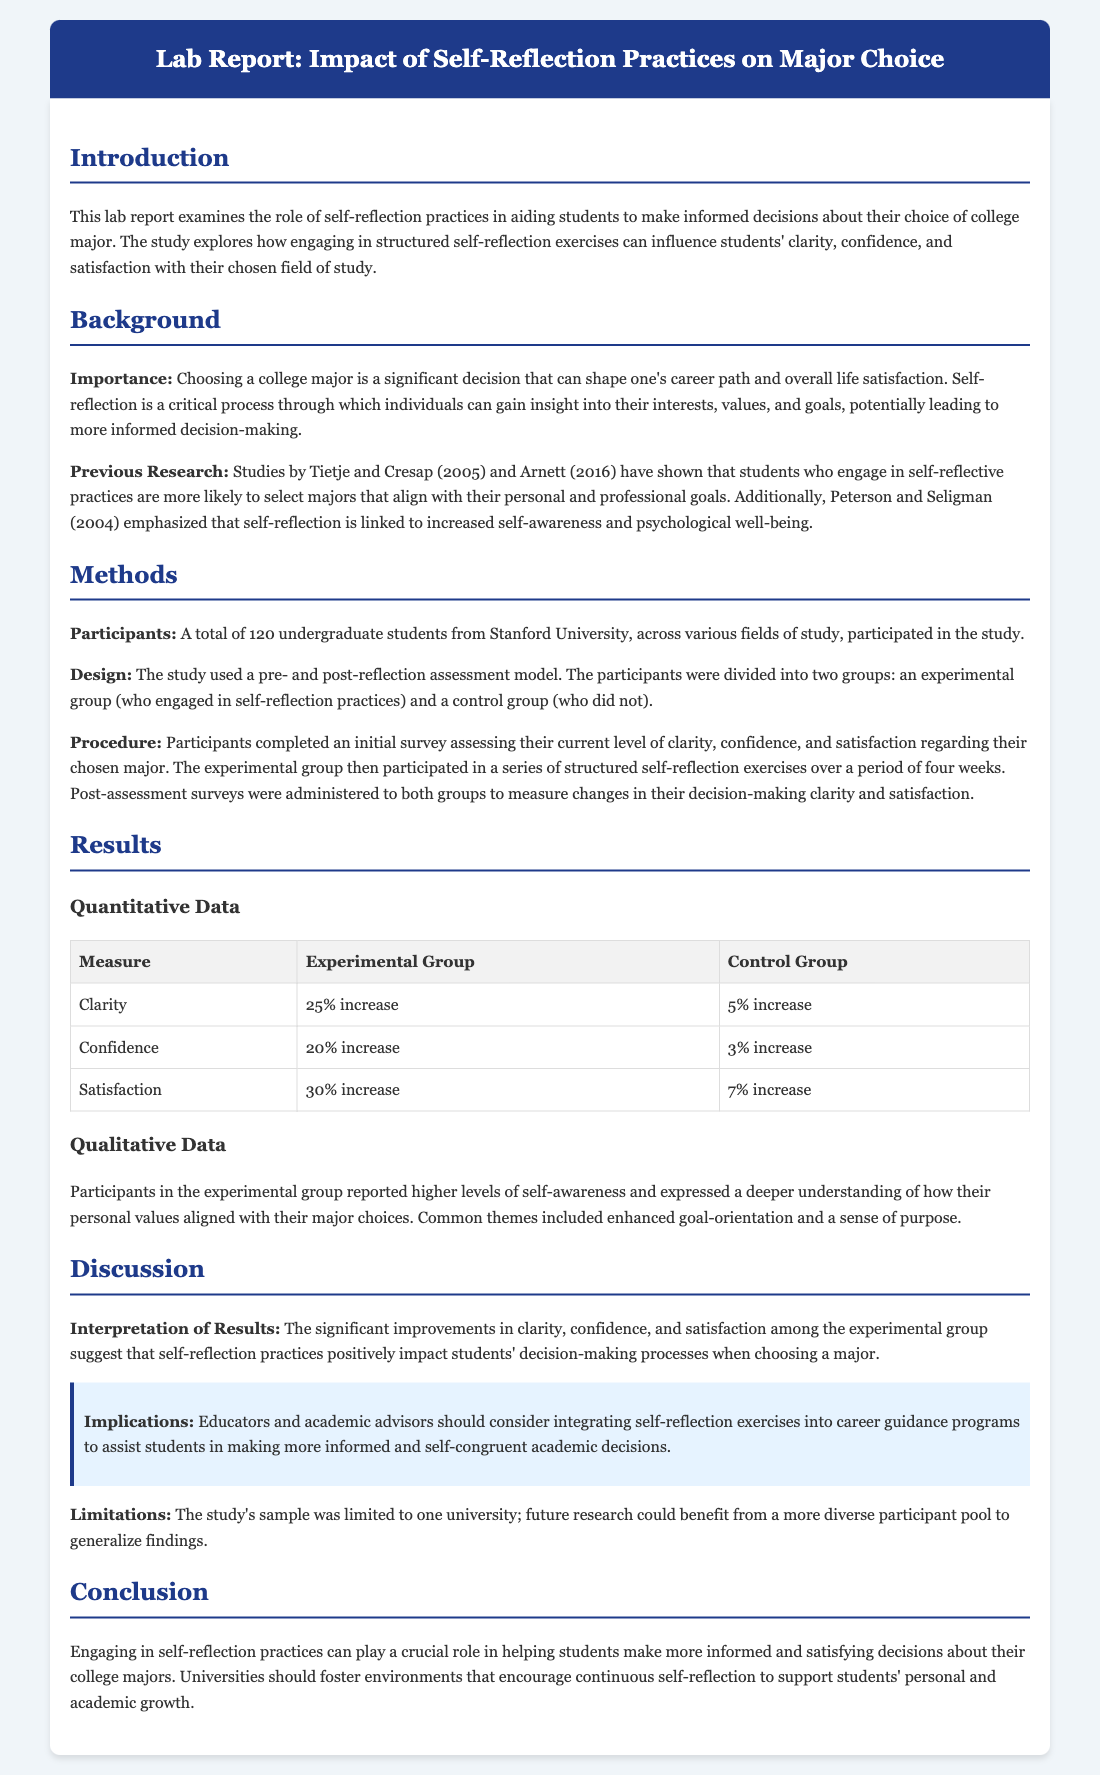What is the title of the lab report? The title of the lab report is stated in the document's header and indicates the focus of the study.
Answer: Impact of Self-Reflection Practices on Decision Making in Choosing a College Major: An Experimental Study with Pre- and Post-Reflection Assessments How many undergraduate students participated in the study? The document mentions the total number of participants in the methods section.
Answer: 120 What was the percentage increase in clarity for the experimental group? The data table provides specific percentages for clarity in both groups, highlighting the effectiveness of the experimental group's practices.
Answer: 25% increase Which group engaged in self-reflection practices? The document outlines the experimental design and the groups involved in the study.
Answer: Experimental group What theme was commonly reported by participants in the experimental group? The qualitative data section provides insights into the common experiences of the experimental group participants.
Answer: Enhanced goal-orientation What should educators consider integrating into career guidance programs? The discussion section emphasizes practical recommendations based on the study's findings.
Answer: Self-reflection exercises What limitation does the study acknowledge? The limitations section highlights a specific aspect of the study that could be improved in future research.
Answer: Limited to one university What was the percentage increase in satisfaction for the control group? The data table includes the satisfaction change in the control group, indicating their results compared to the experimental group.
Answer: 7% increase 